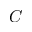<formula> <loc_0><loc_0><loc_500><loc_500>C</formula> 